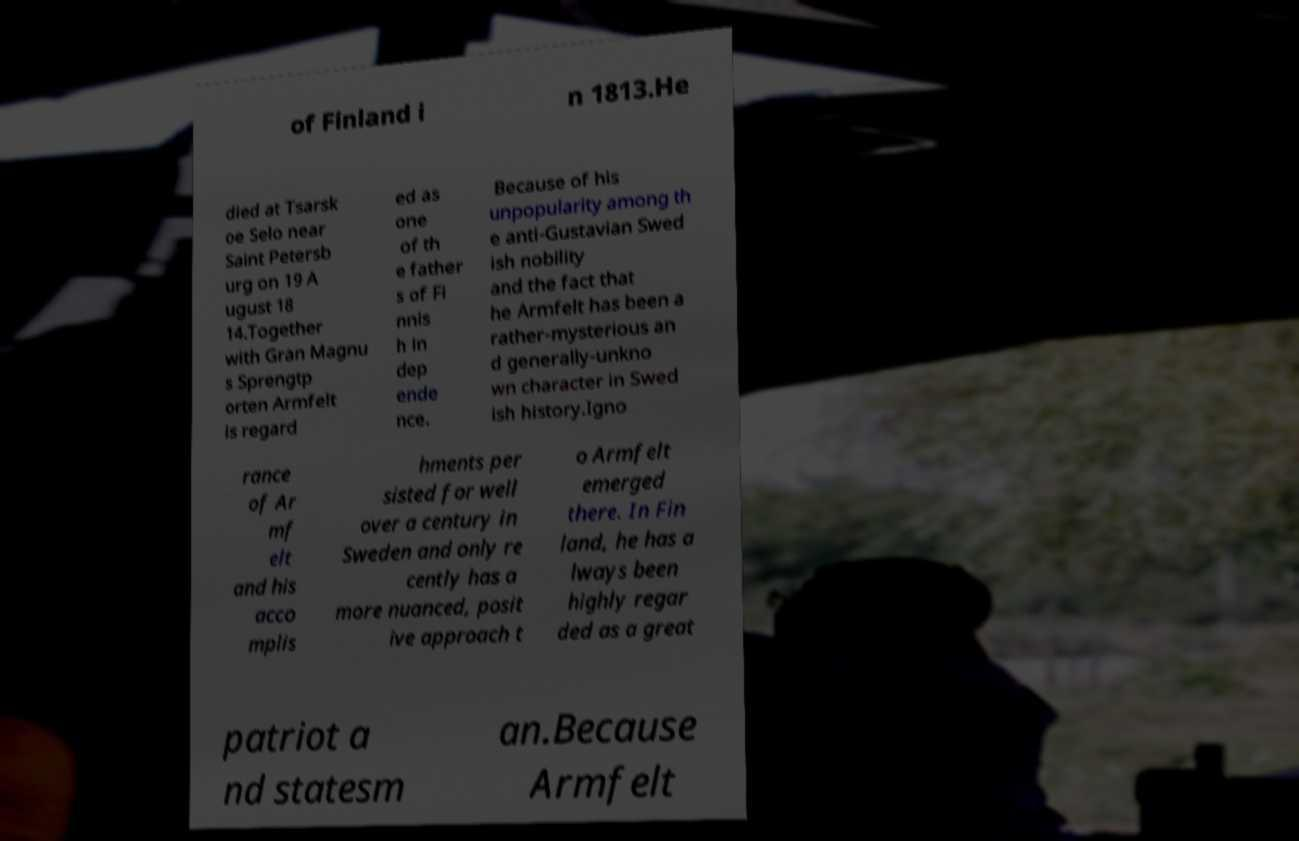Please read and relay the text visible in this image. What does it say? of Finland i n 1813.He died at Tsarsk oe Selo near Saint Petersb urg on 19 A ugust 18 14.Together with Gran Magnu s Sprengtp orten Armfelt is regard ed as one of th e father s of Fi nnis h in dep ende nce. Because of his unpopularity among th e anti-Gustavian Swed ish nobility and the fact that he Armfelt has been a rather-mysterious an d generally-unkno wn character in Swed ish history.Igno rance of Ar mf elt and his acco mplis hments per sisted for well over a century in Sweden and only re cently has a more nuanced, posit ive approach t o Armfelt emerged there. In Fin land, he has a lways been highly regar ded as a great patriot a nd statesm an.Because Armfelt 